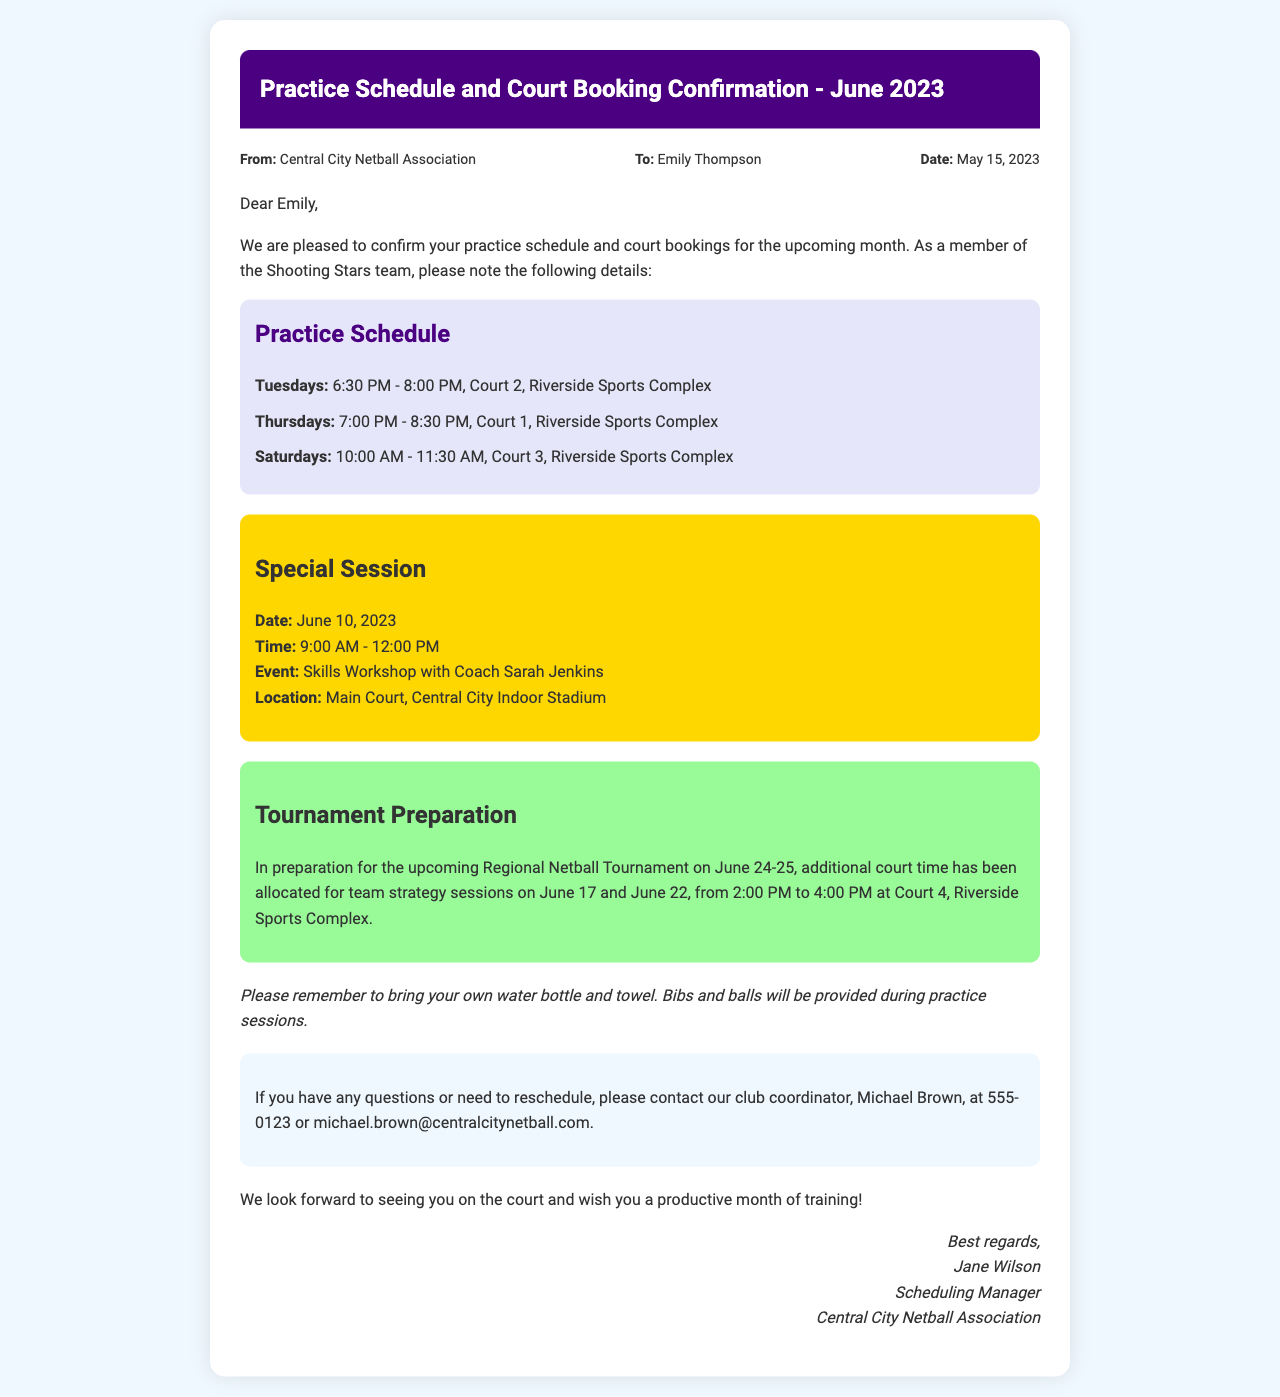What are the practice days? The practice days listed in the document are Tuesdays, Thursdays, and Saturdays.
Answer: Tuesdays, Thursdays, Saturdays What time is the Skills Workshop on June 10? The document states the Skills Workshop will be held from 9:00 AM to 12:00 PM.
Answer: 9:00 AM - 12:00 PM How many court sessions are scheduled for tournament preparation? There are two additional court sessions allocated for tournament preparation on June 17 and June 22.
Answer: Two What is the location for the practice sessions? The practice sessions are held at Riverside Sports Complex as specified in the document.
Answer: Riverside Sports Complex Who is the club coordinator? The document lists Michael Brown as the club coordinator for contact.
Answer: Michael Brown What should players bring to practice? The document advises players to bring their own water bottle and towel.
Answer: Water bottle and towel How long is the regular Tuesday practice session? The Tuesday practice session is scheduled for 1.5 hours, from 6:30 PM to 8:00 PM.
Answer: 1.5 hours What type of event is scheduled for June 10? The event scheduled for June 10 is a Skills Workshop with Coach Sarah Jenkins.
Answer: Skills Workshop What is the focus of the additional sessions on June 17 and June 22? The focus of the additional sessions is for team strategy sessions in preparation for the tournament.
Answer: Team strategy sessions 